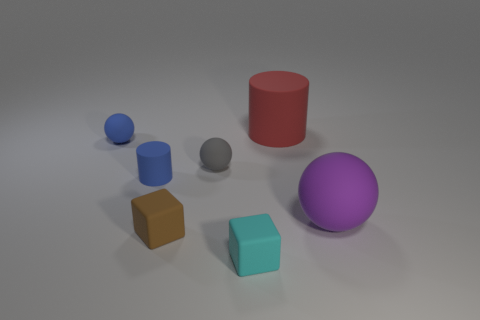Subtract all big spheres. How many spheres are left? 2 Subtract all spheres. How many objects are left? 4 Add 2 tiny blue spheres. How many objects exist? 9 Subtract all blue spheres. How many spheres are left? 2 Subtract all cyan spheres. Subtract all red blocks. How many spheres are left? 3 Subtract all big purple rubber cylinders. Subtract all blue rubber cylinders. How many objects are left? 6 Add 1 rubber cylinders. How many rubber cylinders are left? 3 Add 3 red cylinders. How many red cylinders exist? 4 Subtract 0 red cubes. How many objects are left? 7 